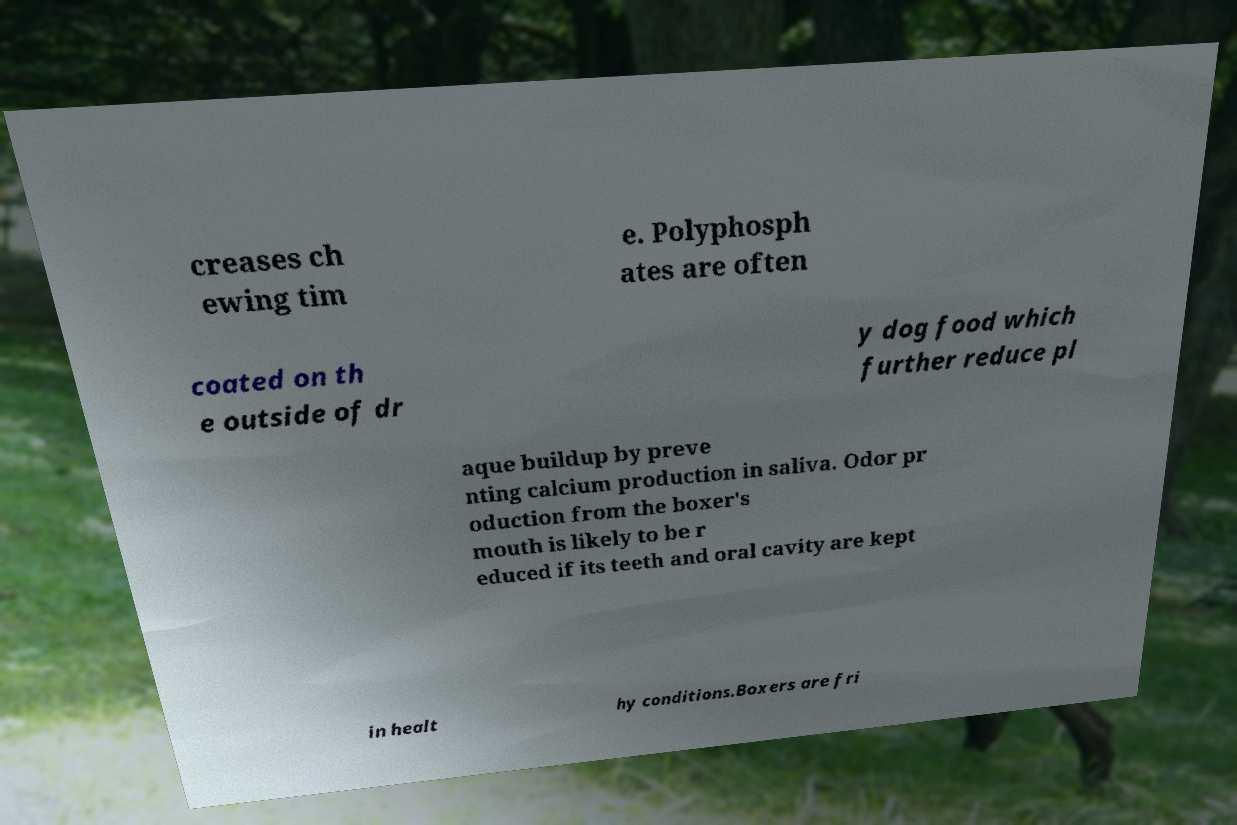I need the written content from this picture converted into text. Can you do that? creases ch ewing tim e. Polyphosph ates are often coated on th e outside of dr y dog food which further reduce pl aque buildup by preve nting calcium production in saliva. Odor pr oduction from the boxer's mouth is likely to be r educed if its teeth and oral cavity are kept in healt hy conditions.Boxers are fri 